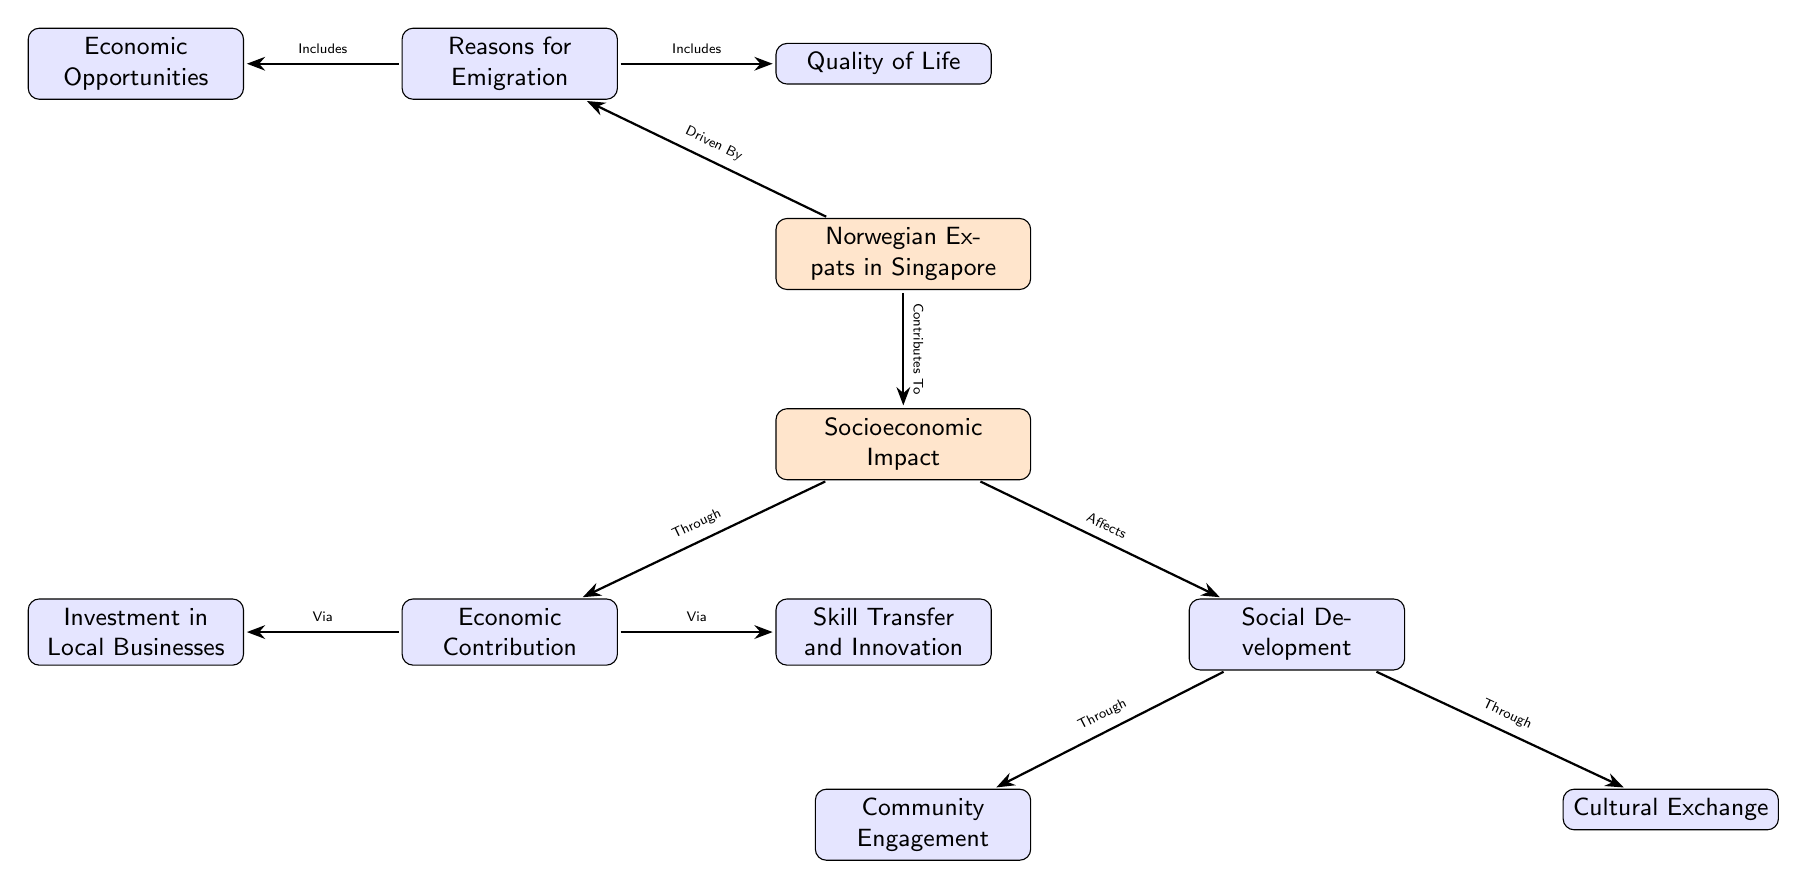What are the two main reasons for emigration? The diagram lists two main reasons under the node titled "Reasons for Emigration": "Economic Opportunities" and "Quality of Life."
Answer: Economic Opportunities, Quality of Life How many nodes are there in total? Counting all the distinct nodes in the diagram, including both main and sub-nodes, we have a total of 8 nodes.
Answer: 8 What does the "Socioeconomic Impact" lead to? The "Socioeconomic Impact" node branches to two main effects: "Economic Contribution" and "Social Development."
Answer: Economic Contribution, Social Development What type of contribution leads to local businesses? The diagram shows a direct connection, indicating that "Investment in Local Businesses" is part of the "Economic Contribution."
Answer: Investment in Local Businesses Which aspect of socioeconomic impact is related to community involvement? The node "Community Engagement" is directly associated with the "Social Development" node, indicating its relation to community involvement.
Answer: Community Engagement What two ways does "Economic Contribution" affect the socioeconomic impact? The "Economic Contribution" node has two sub-nodes: "Investment in Local Businesses" and "Skill Transfer and Innovation," showing how it impacts the local economy.
Answer: Investment in Local Businesses, Skill Transfer and Innovation How does "Social Development" influence cultural interactions? "Social Development" leads to "Cultural Exchange" indicating that it affects interactions between different cultures within the community.
Answer: Cultural Exchange Name one of the nodes that shows a positive effect of Norwegian expats in Singapore. The diagram indicates that both "Economic Contribution" and "Social Development" are positive effects of Norwegian expats, but one example is "Economic Contribution."
Answer: Economic Contribution 